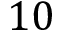Convert formula to latex. <formula><loc_0><loc_0><loc_500><loc_500>1 0</formula> 